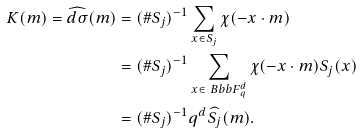Convert formula to latex. <formula><loc_0><loc_0><loc_500><loc_500>K ( m ) = \widehat { d \sigma } ( m ) & = ( \# S _ { j } ) ^ { - 1 } \sum _ { x \in S _ { j } } \chi ( - x \cdot m ) \\ & = ( \# S _ { j } ) ^ { - 1 } \sum _ { x \in { \ B b b F } _ { q } ^ { d } } \chi ( - x \cdot m ) S _ { j } ( x ) \\ & = ( \# S _ { j } ) ^ { - 1 } q ^ { d } \widehat { S _ { j } } ( m ) .</formula> 